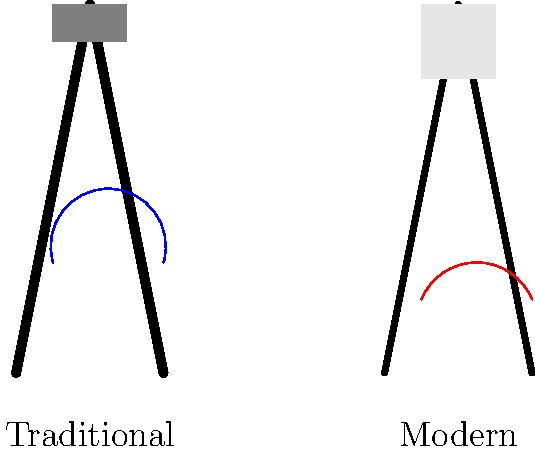Compare the ergonomics of a traditional paintbrush and a modern digital pen. Which tool is likely to cause less wrist strain during prolonged use, and why? To compare the ergonomics of a traditional paintbrush and a modern digital pen, we need to consider several factors:

1. Grip angle: 
   - Traditional paintbrush: Typically held at a steeper angle (about 60-70 degrees from horizontal)
   - Modern digital pen: Usually held at a shallower angle (about 40-50 degrees from horizontal)

2. Weight distribution:
   - Traditional paintbrush: Weight concentrated at the brush end
   - Modern digital pen: More evenly distributed weight

3. Pressure required:
   - Traditional paintbrush: Varies depending on desired effect, can require significant pressure
   - Modern digital pen: Consistent, usually requires less pressure

4. Range of motion:
   - Traditional paintbrush: Requires larger arm and wrist movements
   - Modern digital pen: Allows for smaller, more controlled movements

5. Wrist position:
   - Traditional paintbrush: Often requires the wrist to be bent at more extreme angles
   - Modern digital pen: Allows for a more neutral wrist position

The modern digital pen is likely to cause less wrist strain during prolonged use because:

1. The shallower grip angle promotes a more neutral wrist position.
2. Even weight distribution reduces fatigue on specific muscle groups.
3. Consistent and lower pressure requirements reduce overall strain.
4. Smaller range of motion decreases the likelihood of repetitive strain injuries.
5. The ability to maintain a more neutral wrist position reduces the risk of carpal tunnel syndrome and other wrist-related issues.

These factors combined lead to better ergonomics and less wrist strain for the modern digital pen during extended use.
Answer: Modern digital pen; allows more neutral wrist position and requires less pressure. 